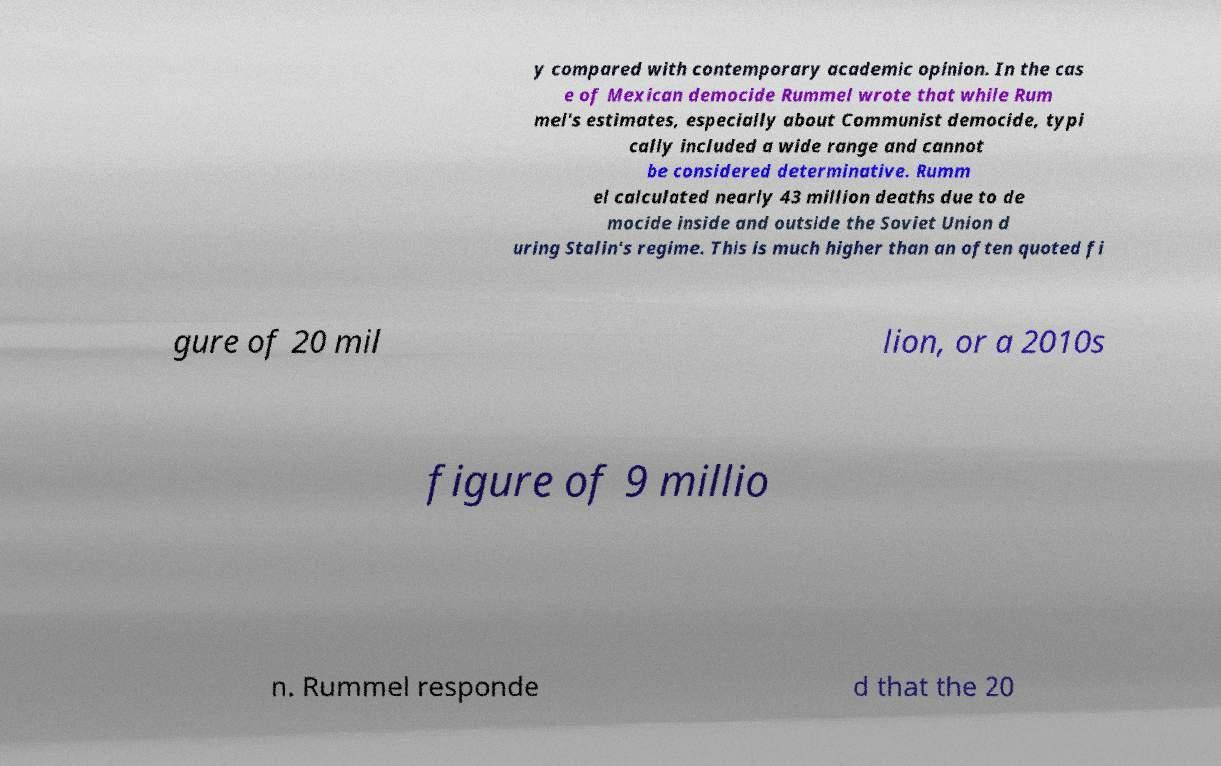Could you assist in decoding the text presented in this image and type it out clearly? y compared with contemporary academic opinion. In the cas e of Mexican democide Rummel wrote that while Rum mel's estimates, especially about Communist democide, typi cally included a wide range and cannot be considered determinative. Rumm el calculated nearly 43 million deaths due to de mocide inside and outside the Soviet Union d uring Stalin's regime. This is much higher than an often quoted fi gure of 20 mil lion, or a 2010s figure of 9 millio n. Rummel responde d that the 20 